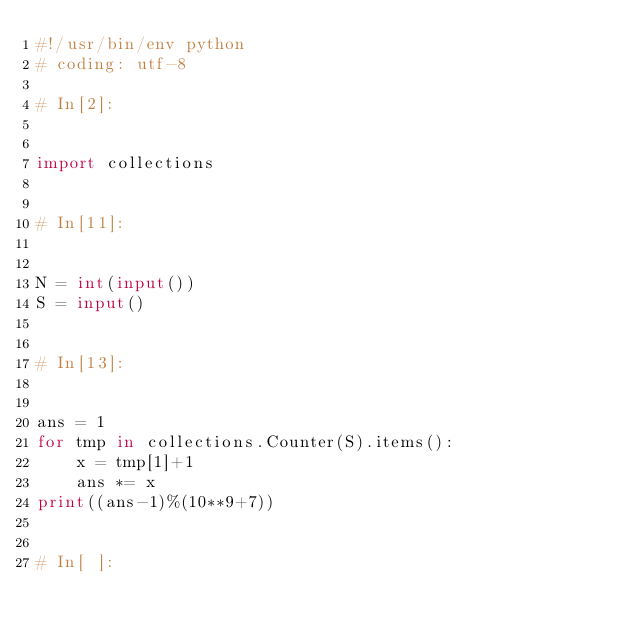<code> <loc_0><loc_0><loc_500><loc_500><_Python_>#!/usr/bin/env python
# coding: utf-8

# In[2]:


import collections


# In[11]:


N = int(input())
S = input()


# In[13]:


ans = 1
for tmp in collections.Counter(S).items():
    x = tmp[1]+1
    ans *= x
print((ans-1)%(10**9+7))


# In[ ]:




</code> 